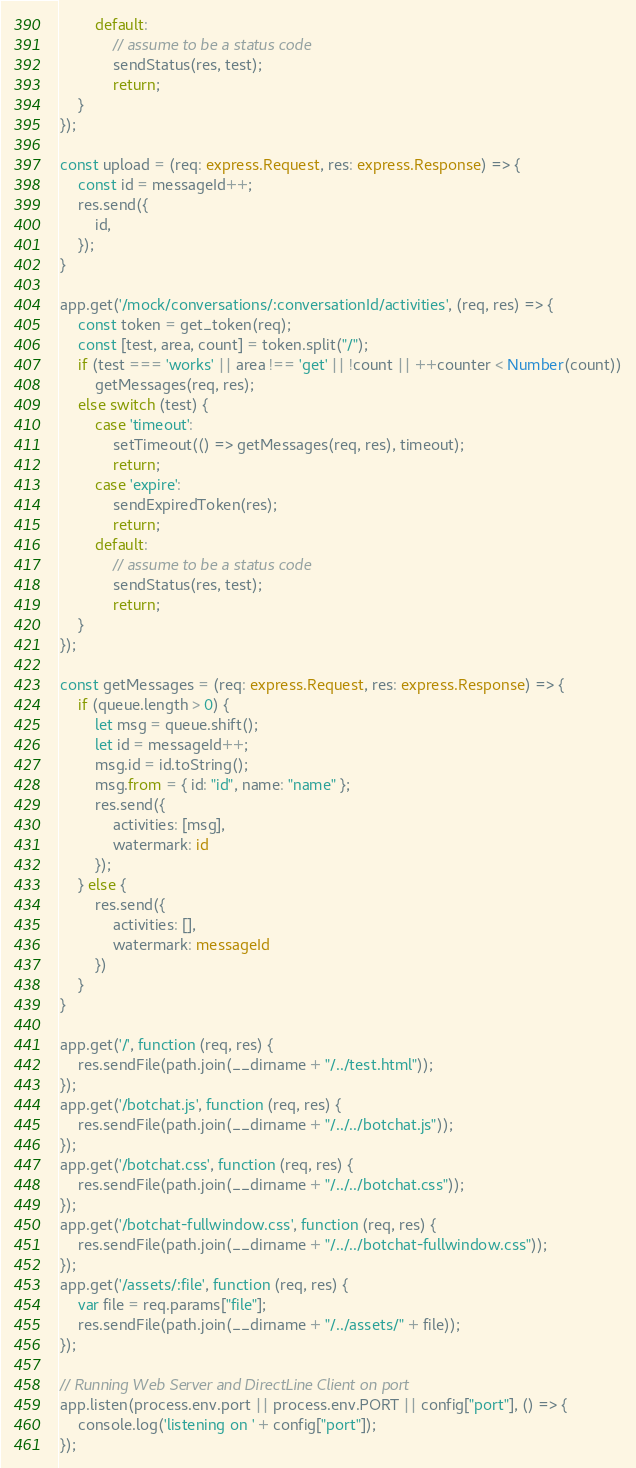<code> <loc_0><loc_0><loc_500><loc_500><_TypeScript_>        default:
            // assume to be a status code
            sendStatus(res, test);
            return;
    }
});

const upload = (req: express.Request, res: express.Response) => {
    const id = messageId++;
    res.send({
        id,
    });
}

app.get('/mock/conversations/:conversationId/activities', (req, res) => {
    const token = get_token(req);
    const [test, area, count] = token.split("/");
    if (test === 'works' || area !== 'get' || !count || ++counter < Number(count))
        getMessages(req, res);
    else switch (test) {
        case 'timeout':
            setTimeout(() => getMessages(req, res), timeout);
            return;
        case 'expire':
            sendExpiredToken(res);
            return;
        default:
            // assume to be a status code
            sendStatus(res, test);
            return;
    }
});

const getMessages = (req: express.Request, res: express.Response) => {
    if (queue.length > 0) {
        let msg = queue.shift();
        let id = messageId++;
        msg.id = id.toString();
        msg.from = { id: "id", name: "name" };
        res.send({
            activities: [msg],
            watermark: id
        });
    } else {
        res.send({
            activities: [],
            watermark: messageId
        })
    }
}

app.get('/', function (req, res) {
    res.sendFile(path.join(__dirname + "/../test.html"));
});
app.get('/botchat.js', function (req, res) {
    res.sendFile(path.join(__dirname + "/../../botchat.js"));
});
app.get('/botchat.css', function (req, res) {
    res.sendFile(path.join(__dirname + "/../../botchat.css"));
});
app.get('/botchat-fullwindow.css', function (req, res) {
    res.sendFile(path.join(__dirname + "/../../botchat-fullwindow.css"));
});
app.get('/assets/:file', function (req, res) {
    var file = req.params["file"];
    res.sendFile(path.join(__dirname + "/../assets/" + file));
});

// Running Web Server and DirectLine Client on port
app.listen(process.env.port || process.env.PORT || config["port"], () => {
    console.log('listening on ' + config["port"]);
});</code> 